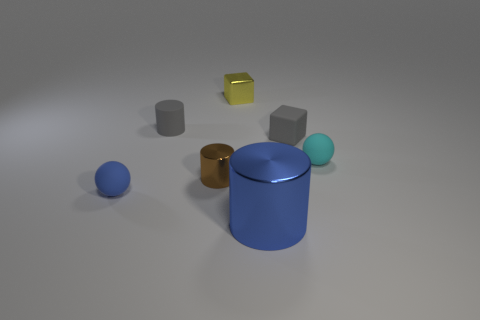Add 2 large cylinders. How many objects exist? 9 Subtract all balls. How many objects are left? 5 Add 3 blue matte spheres. How many blue matte spheres are left? 4 Add 4 gray things. How many gray things exist? 6 Subtract 1 yellow cubes. How many objects are left? 6 Subtract all brown cylinders. Subtract all small brown metallic things. How many objects are left? 5 